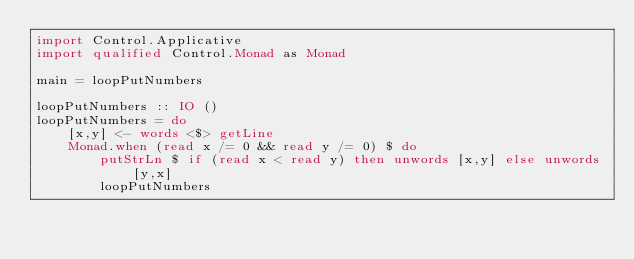Convert code to text. <code><loc_0><loc_0><loc_500><loc_500><_Haskell_>import Control.Applicative
import qualified Control.Monad as Monad

main = loopPutNumbers

loopPutNumbers :: IO ()
loopPutNumbers = do
    [x,y] <- words <$> getLine
    Monad.when (read x /= 0 && read y /= 0) $ do
        putStrLn $ if (read x < read y) then unwords [x,y] else unwords [y,x]
        loopPutNumbers</code> 